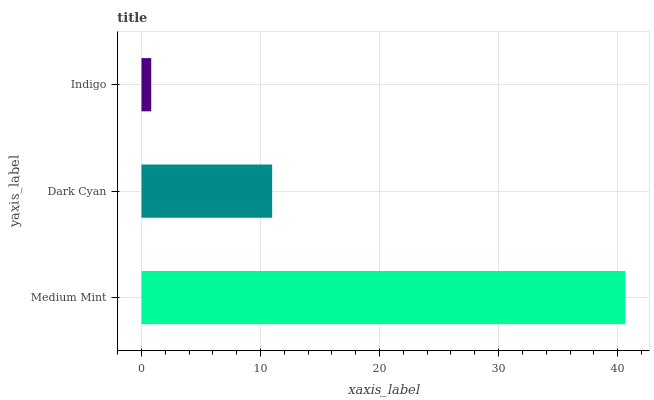Is Indigo the minimum?
Answer yes or no. Yes. Is Medium Mint the maximum?
Answer yes or no. Yes. Is Dark Cyan the minimum?
Answer yes or no. No. Is Dark Cyan the maximum?
Answer yes or no. No. Is Medium Mint greater than Dark Cyan?
Answer yes or no. Yes. Is Dark Cyan less than Medium Mint?
Answer yes or no. Yes. Is Dark Cyan greater than Medium Mint?
Answer yes or no. No. Is Medium Mint less than Dark Cyan?
Answer yes or no. No. Is Dark Cyan the high median?
Answer yes or no. Yes. Is Dark Cyan the low median?
Answer yes or no. Yes. Is Indigo the high median?
Answer yes or no. No. Is Medium Mint the low median?
Answer yes or no. No. 